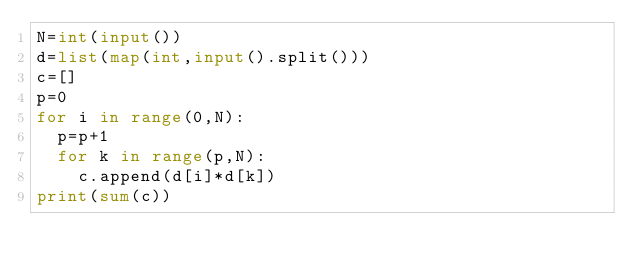<code> <loc_0><loc_0><loc_500><loc_500><_Python_>N=int(input())
d=list(map(int,input().split()))
c=[]
p=0
for i in range(0,N):
  p=p+1   
  for k in range(p,N):
    c.append(d[i]*d[k])
print(sum(c))</code> 